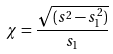Convert formula to latex. <formula><loc_0><loc_0><loc_500><loc_500>\chi = \frac { \sqrt { ( s ^ { 2 } - s _ { 1 } ^ { 2 } ) } } { s _ { 1 } }</formula> 